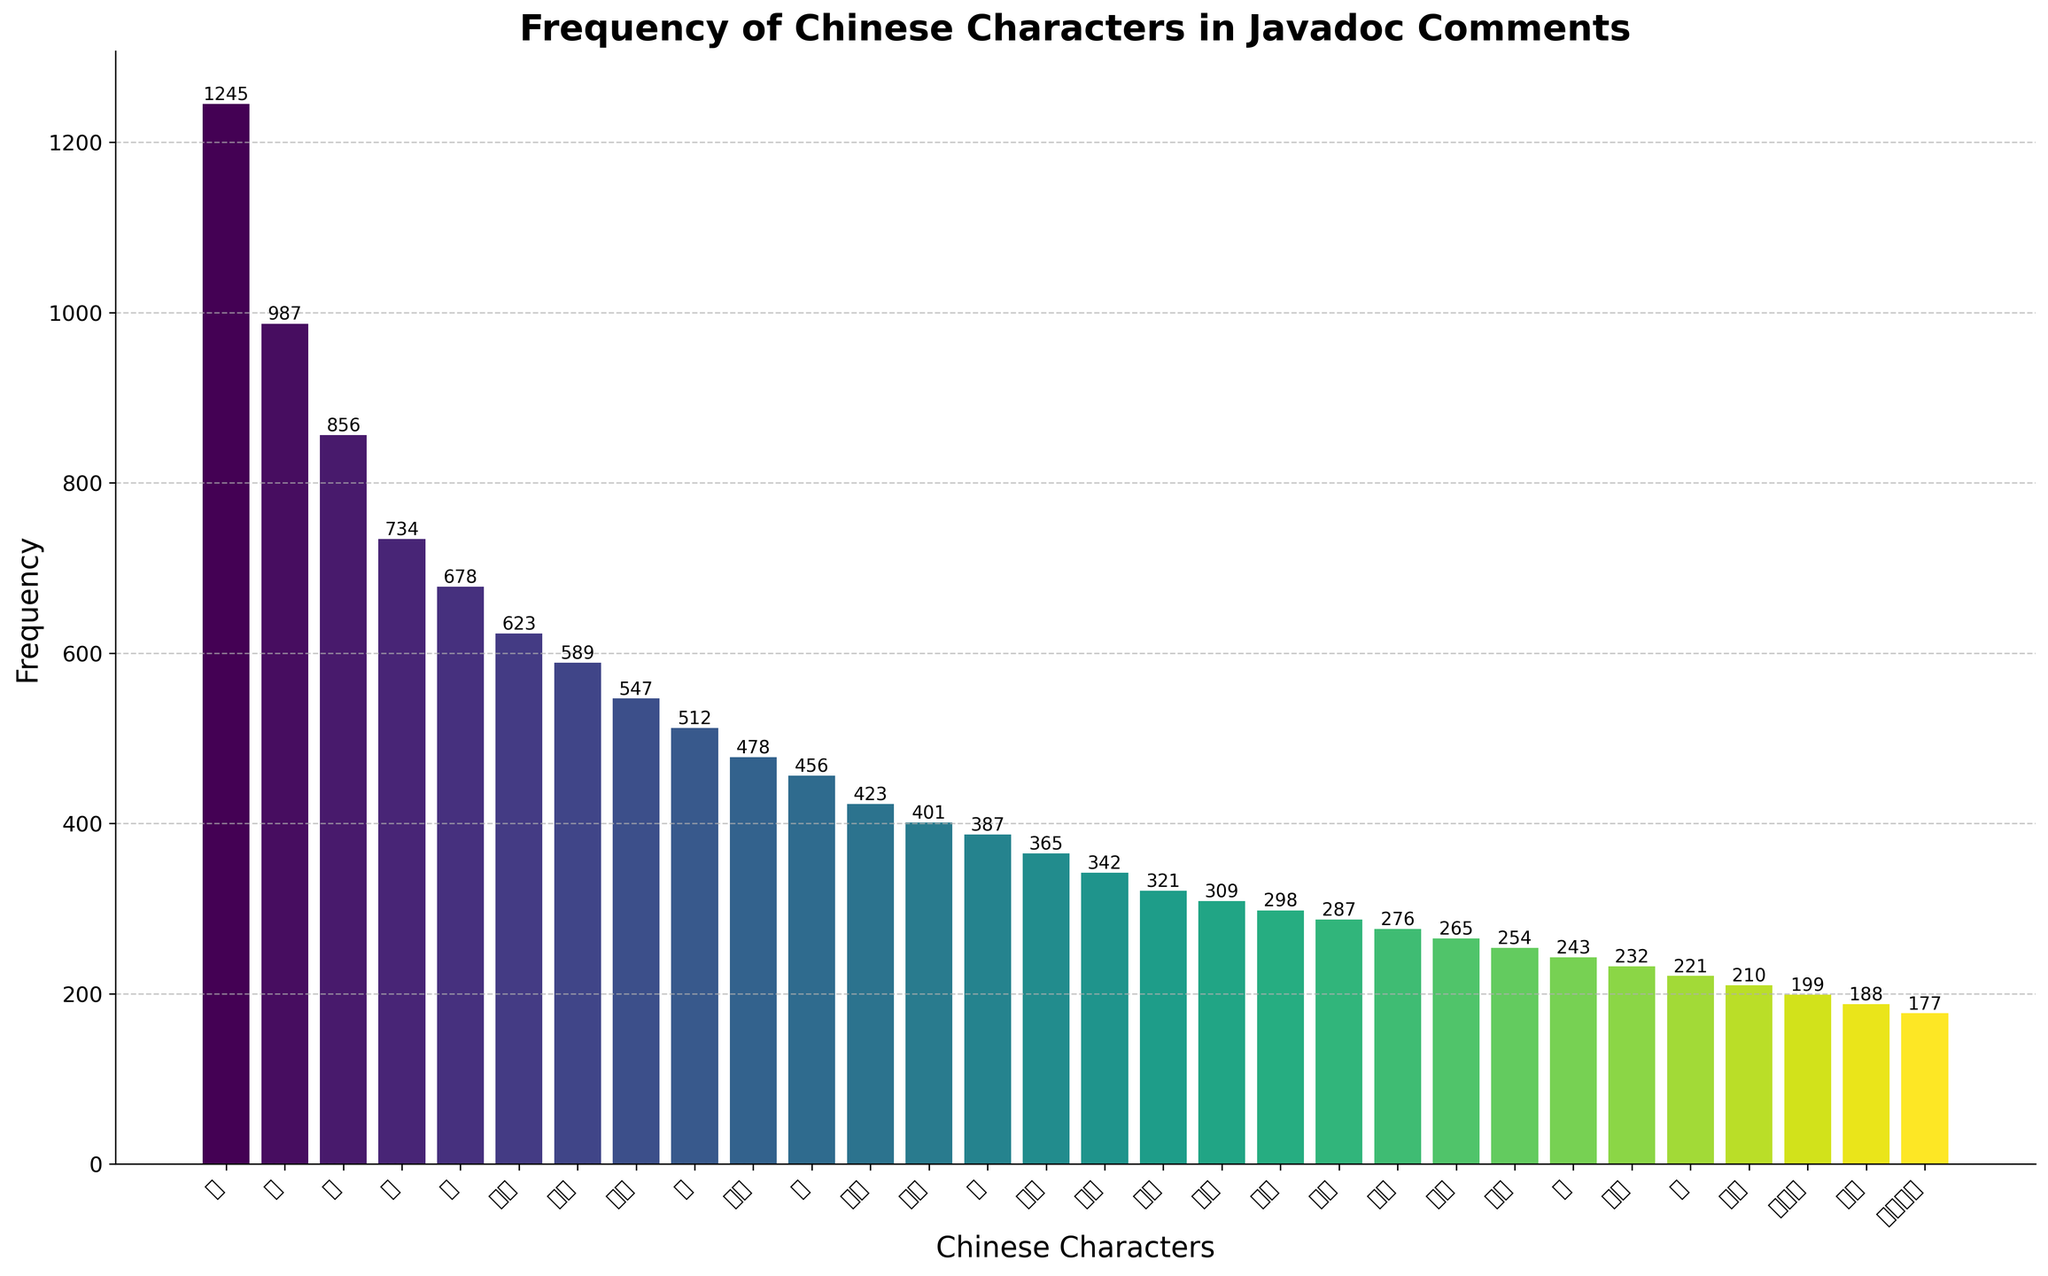what is the most common Chinese character in Javadoc comments? The most common character is the one with the highest frequency bar. By inspecting the tallest bar, we can see the character "的" has the highest frequency of 1245.
Answer: 的 What is the frequency difference between the characters "是" and "了"? To find the difference, subtract the frequency of "了" from "是". The frequencies are 987 for "是" and 678 for "了". Therefore, 987 - 678 = 309.
Answer: 309 How many characters have a frequency greater than 500? Count the bars with heights above 500. The characters are 的, 是, 在, 和, 了, 方法, 参数, and 返回. This totals 8 characters.
Answer: 8 Which character has the lowest frequency and what is its value? The character with the shortest bar has the lowest frequency. The character "构造函数" has the lowest frequency at 177.
Answer: 构造函数 and 177 What is the average frequency of the characters "值," "类," and "对象"? Add the frequencies of "值" (387), "类" (456), and "对象" (423), then divide by 3. (387 + 456 + 423) / 3 = 1266 / 3 = 422.
Answer: 422 How many characters have frequencies between 300 and 400? Identify the bars with heights between 300 and 400. They correspond to "值," "一个," "使用," "实现," "接口," "数据," and "异常." This totals 7 characters.
Answer: 7 What is the total frequency of the top 3 most common characters? Sum the frequencies of the characters 的 (1245), 是 (987), 在 (856). The total frequency is 1245 + 987 + 856 = 3088.
Answer: 3088 Which character's frequency is closest to the average frequency of the entire dataset? Compute the sum of frequencies of all characters and divide by the number of characters. Sum = 14509, average = 14509 / 30 ≈ 484. The character closest to 484 is "用于" with a frequency of 478.
Answer: 用于 